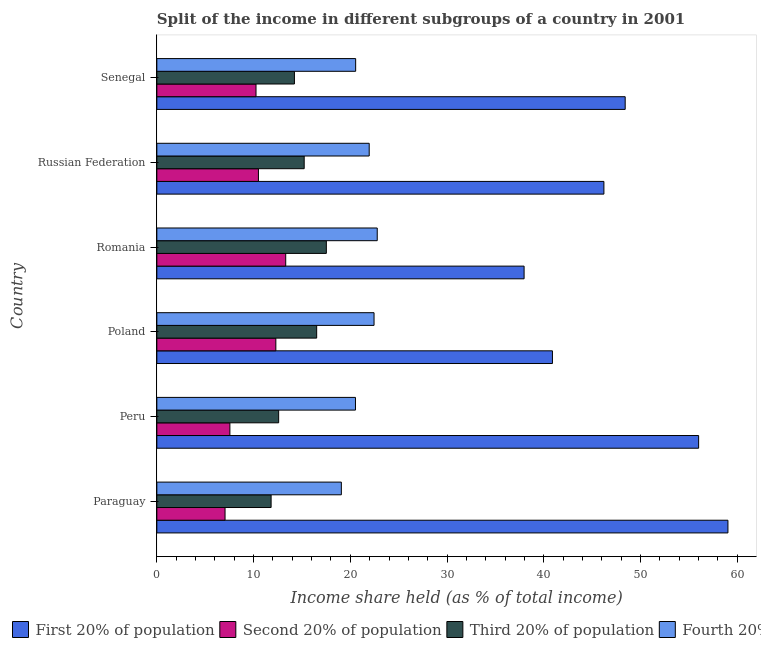How many different coloured bars are there?
Provide a short and direct response. 4. How many groups of bars are there?
Ensure brevity in your answer.  6. What is the label of the 1st group of bars from the top?
Offer a very short reply. Senegal. In how many cases, is the number of bars for a given country not equal to the number of legend labels?
Give a very brief answer. 0. What is the share of the income held by fourth 20% of the population in Russian Federation?
Your answer should be very brief. 21.95. Across all countries, what is the maximum share of the income held by first 20% of the population?
Your response must be concise. 59.03. Across all countries, what is the minimum share of the income held by fourth 20% of the population?
Ensure brevity in your answer.  19.07. In which country was the share of the income held by first 20% of the population maximum?
Provide a succinct answer. Paraguay. In which country was the share of the income held by second 20% of the population minimum?
Offer a very short reply. Paraguay. What is the total share of the income held by first 20% of the population in the graph?
Give a very brief answer. 288.5. What is the difference between the share of the income held by first 20% of the population in Paraguay and the share of the income held by third 20% of the population in Peru?
Make the answer very short. 46.44. What is the average share of the income held by third 20% of the population per country?
Ensure brevity in your answer.  14.65. What is the difference between the share of the income held by fourth 20% of the population and share of the income held by first 20% of the population in Russian Federation?
Keep it short and to the point. -24.26. In how many countries, is the share of the income held by first 20% of the population greater than 54 %?
Keep it short and to the point. 2. Is the share of the income held by third 20% of the population in Romania less than that in Russian Federation?
Provide a succinct answer. No. Is the difference between the share of the income held by first 20% of the population in Poland and Senegal greater than the difference between the share of the income held by second 20% of the population in Poland and Senegal?
Ensure brevity in your answer.  No. What is the difference between the highest and the second highest share of the income held by second 20% of the population?
Provide a short and direct response. 1.02. What is the difference between the highest and the lowest share of the income held by second 20% of the population?
Your response must be concise. 6.27. Is the sum of the share of the income held by first 20% of the population in Peru and Romania greater than the maximum share of the income held by fourth 20% of the population across all countries?
Provide a succinct answer. Yes. Is it the case that in every country, the sum of the share of the income held by third 20% of the population and share of the income held by first 20% of the population is greater than the sum of share of the income held by fourth 20% of the population and share of the income held by second 20% of the population?
Make the answer very short. Yes. What does the 4th bar from the top in Russian Federation represents?
Your answer should be compact. First 20% of population. What does the 2nd bar from the bottom in Poland represents?
Offer a terse response. Second 20% of population. How many countries are there in the graph?
Provide a short and direct response. 6. What is the difference between two consecutive major ticks on the X-axis?
Ensure brevity in your answer.  10. Does the graph contain any zero values?
Your response must be concise. No. Does the graph contain grids?
Provide a short and direct response. No. Where does the legend appear in the graph?
Make the answer very short. Bottom left. How are the legend labels stacked?
Keep it short and to the point. Horizontal. What is the title of the graph?
Provide a short and direct response. Split of the income in different subgroups of a country in 2001. What is the label or title of the X-axis?
Provide a succinct answer. Income share held (as % of total income). What is the label or title of the Y-axis?
Make the answer very short. Country. What is the Income share held (as % of total income) in First 20% of population in Paraguay?
Keep it short and to the point. 59.03. What is the Income share held (as % of total income) of Second 20% of population in Paraguay?
Make the answer very short. 7.05. What is the Income share held (as % of total income) in Third 20% of population in Paraguay?
Provide a short and direct response. 11.81. What is the Income share held (as % of total income) of Fourth 20% of population in Paraguay?
Offer a very short reply. 19.07. What is the Income share held (as % of total income) of Second 20% of population in Peru?
Keep it short and to the point. 7.55. What is the Income share held (as % of total income) in Third 20% of population in Peru?
Your answer should be compact. 12.59. What is the Income share held (as % of total income) in Fourth 20% of population in Peru?
Your response must be concise. 20.53. What is the Income share held (as % of total income) of First 20% of population in Poland?
Your response must be concise. 40.89. What is the Income share held (as % of total income) in Third 20% of population in Poland?
Provide a succinct answer. 16.52. What is the Income share held (as % of total income) of Fourth 20% of population in Poland?
Make the answer very short. 22.45. What is the Income share held (as % of total income) in First 20% of population in Romania?
Your answer should be compact. 37.96. What is the Income share held (as % of total income) in Second 20% of population in Romania?
Offer a very short reply. 13.32. What is the Income share held (as % of total income) in Third 20% of population in Romania?
Provide a short and direct response. 17.52. What is the Income share held (as % of total income) of Fourth 20% of population in Romania?
Offer a terse response. 22.78. What is the Income share held (as % of total income) of First 20% of population in Russian Federation?
Make the answer very short. 46.21. What is the Income share held (as % of total income) of Second 20% of population in Russian Federation?
Make the answer very short. 10.5. What is the Income share held (as % of total income) of Third 20% of population in Russian Federation?
Make the answer very short. 15.23. What is the Income share held (as % of total income) of Fourth 20% of population in Russian Federation?
Offer a terse response. 21.95. What is the Income share held (as % of total income) in First 20% of population in Senegal?
Offer a terse response. 48.41. What is the Income share held (as % of total income) of Second 20% of population in Senegal?
Give a very brief answer. 10.25. What is the Income share held (as % of total income) in Third 20% of population in Senegal?
Your answer should be compact. 14.22. What is the Income share held (as % of total income) of Fourth 20% of population in Senegal?
Ensure brevity in your answer.  20.55. Across all countries, what is the maximum Income share held (as % of total income) of First 20% of population?
Your answer should be compact. 59.03. Across all countries, what is the maximum Income share held (as % of total income) of Second 20% of population?
Offer a terse response. 13.32. Across all countries, what is the maximum Income share held (as % of total income) of Third 20% of population?
Give a very brief answer. 17.52. Across all countries, what is the maximum Income share held (as % of total income) in Fourth 20% of population?
Your response must be concise. 22.78. Across all countries, what is the minimum Income share held (as % of total income) in First 20% of population?
Provide a succinct answer. 37.96. Across all countries, what is the minimum Income share held (as % of total income) in Second 20% of population?
Your answer should be very brief. 7.05. Across all countries, what is the minimum Income share held (as % of total income) of Third 20% of population?
Your answer should be very brief. 11.81. Across all countries, what is the minimum Income share held (as % of total income) of Fourth 20% of population?
Give a very brief answer. 19.07. What is the total Income share held (as % of total income) in First 20% of population in the graph?
Give a very brief answer. 288.5. What is the total Income share held (as % of total income) in Second 20% of population in the graph?
Provide a succinct answer. 60.97. What is the total Income share held (as % of total income) of Third 20% of population in the graph?
Keep it short and to the point. 87.89. What is the total Income share held (as % of total income) of Fourth 20% of population in the graph?
Offer a terse response. 127.33. What is the difference between the Income share held (as % of total income) of First 20% of population in Paraguay and that in Peru?
Give a very brief answer. 3.03. What is the difference between the Income share held (as % of total income) in Third 20% of population in Paraguay and that in Peru?
Your response must be concise. -0.78. What is the difference between the Income share held (as % of total income) of Fourth 20% of population in Paraguay and that in Peru?
Provide a short and direct response. -1.46. What is the difference between the Income share held (as % of total income) in First 20% of population in Paraguay and that in Poland?
Provide a short and direct response. 18.14. What is the difference between the Income share held (as % of total income) of Second 20% of population in Paraguay and that in Poland?
Give a very brief answer. -5.25. What is the difference between the Income share held (as % of total income) in Third 20% of population in Paraguay and that in Poland?
Provide a succinct answer. -4.71. What is the difference between the Income share held (as % of total income) in Fourth 20% of population in Paraguay and that in Poland?
Ensure brevity in your answer.  -3.38. What is the difference between the Income share held (as % of total income) of First 20% of population in Paraguay and that in Romania?
Make the answer very short. 21.07. What is the difference between the Income share held (as % of total income) in Second 20% of population in Paraguay and that in Romania?
Give a very brief answer. -6.27. What is the difference between the Income share held (as % of total income) in Third 20% of population in Paraguay and that in Romania?
Keep it short and to the point. -5.71. What is the difference between the Income share held (as % of total income) of Fourth 20% of population in Paraguay and that in Romania?
Provide a short and direct response. -3.71. What is the difference between the Income share held (as % of total income) in First 20% of population in Paraguay and that in Russian Federation?
Provide a succinct answer. 12.82. What is the difference between the Income share held (as % of total income) of Second 20% of population in Paraguay and that in Russian Federation?
Provide a succinct answer. -3.45. What is the difference between the Income share held (as % of total income) of Third 20% of population in Paraguay and that in Russian Federation?
Give a very brief answer. -3.42. What is the difference between the Income share held (as % of total income) of Fourth 20% of population in Paraguay and that in Russian Federation?
Your answer should be compact. -2.88. What is the difference between the Income share held (as % of total income) in First 20% of population in Paraguay and that in Senegal?
Your answer should be compact. 10.62. What is the difference between the Income share held (as % of total income) in Second 20% of population in Paraguay and that in Senegal?
Offer a terse response. -3.2. What is the difference between the Income share held (as % of total income) of Third 20% of population in Paraguay and that in Senegal?
Your response must be concise. -2.41. What is the difference between the Income share held (as % of total income) in Fourth 20% of population in Paraguay and that in Senegal?
Offer a very short reply. -1.48. What is the difference between the Income share held (as % of total income) in First 20% of population in Peru and that in Poland?
Offer a very short reply. 15.11. What is the difference between the Income share held (as % of total income) in Second 20% of population in Peru and that in Poland?
Make the answer very short. -4.75. What is the difference between the Income share held (as % of total income) of Third 20% of population in Peru and that in Poland?
Ensure brevity in your answer.  -3.93. What is the difference between the Income share held (as % of total income) of Fourth 20% of population in Peru and that in Poland?
Your response must be concise. -1.92. What is the difference between the Income share held (as % of total income) of First 20% of population in Peru and that in Romania?
Make the answer very short. 18.04. What is the difference between the Income share held (as % of total income) in Second 20% of population in Peru and that in Romania?
Your response must be concise. -5.77. What is the difference between the Income share held (as % of total income) of Third 20% of population in Peru and that in Romania?
Your response must be concise. -4.93. What is the difference between the Income share held (as % of total income) of Fourth 20% of population in Peru and that in Romania?
Provide a succinct answer. -2.25. What is the difference between the Income share held (as % of total income) of First 20% of population in Peru and that in Russian Federation?
Ensure brevity in your answer.  9.79. What is the difference between the Income share held (as % of total income) of Second 20% of population in Peru and that in Russian Federation?
Offer a very short reply. -2.95. What is the difference between the Income share held (as % of total income) of Third 20% of population in Peru and that in Russian Federation?
Offer a very short reply. -2.64. What is the difference between the Income share held (as % of total income) of Fourth 20% of population in Peru and that in Russian Federation?
Provide a succinct answer. -1.42. What is the difference between the Income share held (as % of total income) of First 20% of population in Peru and that in Senegal?
Your answer should be compact. 7.59. What is the difference between the Income share held (as % of total income) in Third 20% of population in Peru and that in Senegal?
Your answer should be compact. -1.63. What is the difference between the Income share held (as % of total income) in Fourth 20% of population in Peru and that in Senegal?
Ensure brevity in your answer.  -0.02. What is the difference between the Income share held (as % of total income) of First 20% of population in Poland and that in Romania?
Your answer should be compact. 2.93. What is the difference between the Income share held (as % of total income) in Second 20% of population in Poland and that in Romania?
Offer a very short reply. -1.02. What is the difference between the Income share held (as % of total income) in Third 20% of population in Poland and that in Romania?
Provide a short and direct response. -1. What is the difference between the Income share held (as % of total income) in Fourth 20% of population in Poland and that in Romania?
Make the answer very short. -0.33. What is the difference between the Income share held (as % of total income) of First 20% of population in Poland and that in Russian Federation?
Give a very brief answer. -5.32. What is the difference between the Income share held (as % of total income) in Second 20% of population in Poland and that in Russian Federation?
Make the answer very short. 1.8. What is the difference between the Income share held (as % of total income) of Third 20% of population in Poland and that in Russian Federation?
Make the answer very short. 1.29. What is the difference between the Income share held (as % of total income) of Fourth 20% of population in Poland and that in Russian Federation?
Provide a short and direct response. 0.5. What is the difference between the Income share held (as % of total income) in First 20% of population in Poland and that in Senegal?
Give a very brief answer. -7.52. What is the difference between the Income share held (as % of total income) of Second 20% of population in Poland and that in Senegal?
Provide a short and direct response. 2.05. What is the difference between the Income share held (as % of total income) in Third 20% of population in Poland and that in Senegal?
Offer a very short reply. 2.3. What is the difference between the Income share held (as % of total income) in Fourth 20% of population in Poland and that in Senegal?
Your response must be concise. 1.9. What is the difference between the Income share held (as % of total income) in First 20% of population in Romania and that in Russian Federation?
Provide a succinct answer. -8.25. What is the difference between the Income share held (as % of total income) in Second 20% of population in Romania and that in Russian Federation?
Make the answer very short. 2.82. What is the difference between the Income share held (as % of total income) of Third 20% of population in Romania and that in Russian Federation?
Offer a terse response. 2.29. What is the difference between the Income share held (as % of total income) of Fourth 20% of population in Romania and that in Russian Federation?
Keep it short and to the point. 0.83. What is the difference between the Income share held (as % of total income) in First 20% of population in Romania and that in Senegal?
Provide a short and direct response. -10.45. What is the difference between the Income share held (as % of total income) in Second 20% of population in Romania and that in Senegal?
Give a very brief answer. 3.07. What is the difference between the Income share held (as % of total income) of Third 20% of population in Romania and that in Senegal?
Make the answer very short. 3.3. What is the difference between the Income share held (as % of total income) in Fourth 20% of population in Romania and that in Senegal?
Your response must be concise. 2.23. What is the difference between the Income share held (as % of total income) in First 20% of population in Russian Federation and that in Senegal?
Ensure brevity in your answer.  -2.2. What is the difference between the Income share held (as % of total income) of First 20% of population in Paraguay and the Income share held (as % of total income) of Second 20% of population in Peru?
Offer a terse response. 51.48. What is the difference between the Income share held (as % of total income) in First 20% of population in Paraguay and the Income share held (as % of total income) in Third 20% of population in Peru?
Ensure brevity in your answer.  46.44. What is the difference between the Income share held (as % of total income) in First 20% of population in Paraguay and the Income share held (as % of total income) in Fourth 20% of population in Peru?
Provide a short and direct response. 38.5. What is the difference between the Income share held (as % of total income) of Second 20% of population in Paraguay and the Income share held (as % of total income) of Third 20% of population in Peru?
Your response must be concise. -5.54. What is the difference between the Income share held (as % of total income) in Second 20% of population in Paraguay and the Income share held (as % of total income) in Fourth 20% of population in Peru?
Offer a terse response. -13.48. What is the difference between the Income share held (as % of total income) in Third 20% of population in Paraguay and the Income share held (as % of total income) in Fourth 20% of population in Peru?
Keep it short and to the point. -8.72. What is the difference between the Income share held (as % of total income) of First 20% of population in Paraguay and the Income share held (as % of total income) of Second 20% of population in Poland?
Provide a succinct answer. 46.73. What is the difference between the Income share held (as % of total income) of First 20% of population in Paraguay and the Income share held (as % of total income) of Third 20% of population in Poland?
Provide a succinct answer. 42.51. What is the difference between the Income share held (as % of total income) in First 20% of population in Paraguay and the Income share held (as % of total income) in Fourth 20% of population in Poland?
Your answer should be very brief. 36.58. What is the difference between the Income share held (as % of total income) in Second 20% of population in Paraguay and the Income share held (as % of total income) in Third 20% of population in Poland?
Keep it short and to the point. -9.47. What is the difference between the Income share held (as % of total income) of Second 20% of population in Paraguay and the Income share held (as % of total income) of Fourth 20% of population in Poland?
Give a very brief answer. -15.4. What is the difference between the Income share held (as % of total income) of Third 20% of population in Paraguay and the Income share held (as % of total income) of Fourth 20% of population in Poland?
Make the answer very short. -10.64. What is the difference between the Income share held (as % of total income) of First 20% of population in Paraguay and the Income share held (as % of total income) of Second 20% of population in Romania?
Offer a very short reply. 45.71. What is the difference between the Income share held (as % of total income) of First 20% of population in Paraguay and the Income share held (as % of total income) of Third 20% of population in Romania?
Offer a terse response. 41.51. What is the difference between the Income share held (as % of total income) in First 20% of population in Paraguay and the Income share held (as % of total income) in Fourth 20% of population in Romania?
Give a very brief answer. 36.25. What is the difference between the Income share held (as % of total income) in Second 20% of population in Paraguay and the Income share held (as % of total income) in Third 20% of population in Romania?
Provide a short and direct response. -10.47. What is the difference between the Income share held (as % of total income) of Second 20% of population in Paraguay and the Income share held (as % of total income) of Fourth 20% of population in Romania?
Your response must be concise. -15.73. What is the difference between the Income share held (as % of total income) in Third 20% of population in Paraguay and the Income share held (as % of total income) in Fourth 20% of population in Romania?
Give a very brief answer. -10.97. What is the difference between the Income share held (as % of total income) in First 20% of population in Paraguay and the Income share held (as % of total income) in Second 20% of population in Russian Federation?
Provide a short and direct response. 48.53. What is the difference between the Income share held (as % of total income) in First 20% of population in Paraguay and the Income share held (as % of total income) in Third 20% of population in Russian Federation?
Your response must be concise. 43.8. What is the difference between the Income share held (as % of total income) of First 20% of population in Paraguay and the Income share held (as % of total income) of Fourth 20% of population in Russian Federation?
Your answer should be very brief. 37.08. What is the difference between the Income share held (as % of total income) in Second 20% of population in Paraguay and the Income share held (as % of total income) in Third 20% of population in Russian Federation?
Your answer should be very brief. -8.18. What is the difference between the Income share held (as % of total income) of Second 20% of population in Paraguay and the Income share held (as % of total income) of Fourth 20% of population in Russian Federation?
Give a very brief answer. -14.9. What is the difference between the Income share held (as % of total income) of Third 20% of population in Paraguay and the Income share held (as % of total income) of Fourth 20% of population in Russian Federation?
Offer a terse response. -10.14. What is the difference between the Income share held (as % of total income) of First 20% of population in Paraguay and the Income share held (as % of total income) of Second 20% of population in Senegal?
Provide a succinct answer. 48.78. What is the difference between the Income share held (as % of total income) of First 20% of population in Paraguay and the Income share held (as % of total income) of Third 20% of population in Senegal?
Provide a short and direct response. 44.81. What is the difference between the Income share held (as % of total income) in First 20% of population in Paraguay and the Income share held (as % of total income) in Fourth 20% of population in Senegal?
Your answer should be very brief. 38.48. What is the difference between the Income share held (as % of total income) in Second 20% of population in Paraguay and the Income share held (as % of total income) in Third 20% of population in Senegal?
Ensure brevity in your answer.  -7.17. What is the difference between the Income share held (as % of total income) of Third 20% of population in Paraguay and the Income share held (as % of total income) of Fourth 20% of population in Senegal?
Your answer should be compact. -8.74. What is the difference between the Income share held (as % of total income) in First 20% of population in Peru and the Income share held (as % of total income) in Second 20% of population in Poland?
Keep it short and to the point. 43.7. What is the difference between the Income share held (as % of total income) of First 20% of population in Peru and the Income share held (as % of total income) of Third 20% of population in Poland?
Offer a terse response. 39.48. What is the difference between the Income share held (as % of total income) of First 20% of population in Peru and the Income share held (as % of total income) of Fourth 20% of population in Poland?
Make the answer very short. 33.55. What is the difference between the Income share held (as % of total income) of Second 20% of population in Peru and the Income share held (as % of total income) of Third 20% of population in Poland?
Ensure brevity in your answer.  -8.97. What is the difference between the Income share held (as % of total income) in Second 20% of population in Peru and the Income share held (as % of total income) in Fourth 20% of population in Poland?
Make the answer very short. -14.9. What is the difference between the Income share held (as % of total income) of Third 20% of population in Peru and the Income share held (as % of total income) of Fourth 20% of population in Poland?
Provide a short and direct response. -9.86. What is the difference between the Income share held (as % of total income) in First 20% of population in Peru and the Income share held (as % of total income) in Second 20% of population in Romania?
Your response must be concise. 42.68. What is the difference between the Income share held (as % of total income) in First 20% of population in Peru and the Income share held (as % of total income) in Third 20% of population in Romania?
Offer a terse response. 38.48. What is the difference between the Income share held (as % of total income) of First 20% of population in Peru and the Income share held (as % of total income) of Fourth 20% of population in Romania?
Make the answer very short. 33.22. What is the difference between the Income share held (as % of total income) in Second 20% of population in Peru and the Income share held (as % of total income) in Third 20% of population in Romania?
Your answer should be very brief. -9.97. What is the difference between the Income share held (as % of total income) in Second 20% of population in Peru and the Income share held (as % of total income) in Fourth 20% of population in Romania?
Your answer should be compact. -15.23. What is the difference between the Income share held (as % of total income) of Third 20% of population in Peru and the Income share held (as % of total income) of Fourth 20% of population in Romania?
Provide a short and direct response. -10.19. What is the difference between the Income share held (as % of total income) of First 20% of population in Peru and the Income share held (as % of total income) of Second 20% of population in Russian Federation?
Make the answer very short. 45.5. What is the difference between the Income share held (as % of total income) in First 20% of population in Peru and the Income share held (as % of total income) in Third 20% of population in Russian Federation?
Provide a short and direct response. 40.77. What is the difference between the Income share held (as % of total income) in First 20% of population in Peru and the Income share held (as % of total income) in Fourth 20% of population in Russian Federation?
Offer a terse response. 34.05. What is the difference between the Income share held (as % of total income) in Second 20% of population in Peru and the Income share held (as % of total income) in Third 20% of population in Russian Federation?
Provide a short and direct response. -7.68. What is the difference between the Income share held (as % of total income) of Second 20% of population in Peru and the Income share held (as % of total income) of Fourth 20% of population in Russian Federation?
Offer a terse response. -14.4. What is the difference between the Income share held (as % of total income) of Third 20% of population in Peru and the Income share held (as % of total income) of Fourth 20% of population in Russian Federation?
Make the answer very short. -9.36. What is the difference between the Income share held (as % of total income) in First 20% of population in Peru and the Income share held (as % of total income) in Second 20% of population in Senegal?
Your answer should be compact. 45.75. What is the difference between the Income share held (as % of total income) in First 20% of population in Peru and the Income share held (as % of total income) in Third 20% of population in Senegal?
Offer a very short reply. 41.78. What is the difference between the Income share held (as % of total income) of First 20% of population in Peru and the Income share held (as % of total income) of Fourth 20% of population in Senegal?
Provide a short and direct response. 35.45. What is the difference between the Income share held (as % of total income) of Second 20% of population in Peru and the Income share held (as % of total income) of Third 20% of population in Senegal?
Offer a terse response. -6.67. What is the difference between the Income share held (as % of total income) of Third 20% of population in Peru and the Income share held (as % of total income) of Fourth 20% of population in Senegal?
Give a very brief answer. -7.96. What is the difference between the Income share held (as % of total income) in First 20% of population in Poland and the Income share held (as % of total income) in Second 20% of population in Romania?
Give a very brief answer. 27.57. What is the difference between the Income share held (as % of total income) in First 20% of population in Poland and the Income share held (as % of total income) in Third 20% of population in Romania?
Ensure brevity in your answer.  23.37. What is the difference between the Income share held (as % of total income) in First 20% of population in Poland and the Income share held (as % of total income) in Fourth 20% of population in Romania?
Provide a short and direct response. 18.11. What is the difference between the Income share held (as % of total income) of Second 20% of population in Poland and the Income share held (as % of total income) of Third 20% of population in Romania?
Give a very brief answer. -5.22. What is the difference between the Income share held (as % of total income) of Second 20% of population in Poland and the Income share held (as % of total income) of Fourth 20% of population in Romania?
Your answer should be very brief. -10.48. What is the difference between the Income share held (as % of total income) of Third 20% of population in Poland and the Income share held (as % of total income) of Fourth 20% of population in Romania?
Offer a very short reply. -6.26. What is the difference between the Income share held (as % of total income) in First 20% of population in Poland and the Income share held (as % of total income) in Second 20% of population in Russian Federation?
Your response must be concise. 30.39. What is the difference between the Income share held (as % of total income) in First 20% of population in Poland and the Income share held (as % of total income) in Third 20% of population in Russian Federation?
Keep it short and to the point. 25.66. What is the difference between the Income share held (as % of total income) in First 20% of population in Poland and the Income share held (as % of total income) in Fourth 20% of population in Russian Federation?
Your answer should be compact. 18.94. What is the difference between the Income share held (as % of total income) of Second 20% of population in Poland and the Income share held (as % of total income) of Third 20% of population in Russian Federation?
Your answer should be very brief. -2.93. What is the difference between the Income share held (as % of total income) in Second 20% of population in Poland and the Income share held (as % of total income) in Fourth 20% of population in Russian Federation?
Your response must be concise. -9.65. What is the difference between the Income share held (as % of total income) of Third 20% of population in Poland and the Income share held (as % of total income) of Fourth 20% of population in Russian Federation?
Your answer should be compact. -5.43. What is the difference between the Income share held (as % of total income) in First 20% of population in Poland and the Income share held (as % of total income) in Second 20% of population in Senegal?
Keep it short and to the point. 30.64. What is the difference between the Income share held (as % of total income) of First 20% of population in Poland and the Income share held (as % of total income) of Third 20% of population in Senegal?
Your answer should be compact. 26.67. What is the difference between the Income share held (as % of total income) of First 20% of population in Poland and the Income share held (as % of total income) of Fourth 20% of population in Senegal?
Keep it short and to the point. 20.34. What is the difference between the Income share held (as % of total income) of Second 20% of population in Poland and the Income share held (as % of total income) of Third 20% of population in Senegal?
Give a very brief answer. -1.92. What is the difference between the Income share held (as % of total income) of Second 20% of population in Poland and the Income share held (as % of total income) of Fourth 20% of population in Senegal?
Your answer should be compact. -8.25. What is the difference between the Income share held (as % of total income) in Third 20% of population in Poland and the Income share held (as % of total income) in Fourth 20% of population in Senegal?
Give a very brief answer. -4.03. What is the difference between the Income share held (as % of total income) in First 20% of population in Romania and the Income share held (as % of total income) in Second 20% of population in Russian Federation?
Provide a short and direct response. 27.46. What is the difference between the Income share held (as % of total income) in First 20% of population in Romania and the Income share held (as % of total income) in Third 20% of population in Russian Federation?
Offer a very short reply. 22.73. What is the difference between the Income share held (as % of total income) in First 20% of population in Romania and the Income share held (as % of total income) in Fourth 20% of population in Russian Federation?
Your answer should be very brief. 16.01. What is the difference between the Income share held (as % of total income) in Second 20% of population in Romania and the Income share held (as % of total income) in Third 20% of population in Russian Federation?
Keep it short and to the point. -1.91. What is the difference between the Income share held (as % of total income) of Second 20% of population in Romania and the Income share held (as % of total income) of Fourth 20% of population in Russian Federation?
Provide a short and direct response. -8.63. What is the difference between the Income share held (as % of total income) of Third 20% of population in Romania and the Income share held (as % of total income) of Fourth 20% of population in Russian Federation?
Offer a very short reply. -4.43. What is the difference between the Income share held (as % of total income) of First 20% of population in Romania and the Income share held (as % of total income) of Second 20% of population in Senegal?
Provide a succinct answer. 27.71. What is the difference between the Income share held (as % of total income) of First 20% of population in Romania and the Income share held (as % of total income) of Third 20% of population in Senegal?
Your answer should be compact. 23.74. What is the difference between the Income share held (as % of total income) of First 20% of population in Romania and the Income share held (as % of total income) of Fourth 20% of population in Senegal?
Provide a succinct answer. 17.41. What is the difference between the Income share held (as % of total income) of Second 20% of population in Romania and the Income share held (as % of total income) of Fourth 20% of population in Senegal?
Ensure brevity in your answer.  -7.23. What is the difference between the Income share held (as % of total income) in Third 20% of population in Romania and the Income share held (as % of total income) in Fourth 20% of population in Senegal?
Your answer should be compact. -3.03. What is the difference between the Income share held (as % of total income) of First 20% of population in Russian Federation and the Income share held (as % of total income) of Second 20% of population in Senegal?
Offer a terse response. 35.96. What is the difference between the Income share held (as % of total income) of First 20% of population in Russian Federation and the Income share held (as % of total income) of Third 20% of population in Senegal?
Your response must be concise. 31.99. What is the difference between the Income share held (as % of total income) of First 20% of population in Russian Federation and the Income share held (as % of total income) of Fourth 20% of population in Senegal?
Keep it short and to the point. 25.66. What is the difference between the Income share held (as % of total income) in Second 20% of population in Russian Federation and the Income share held (as % of total income) in Third 20% of population in Senegal?
Offer a very short reply. -3.72. What is the difference between the Income share held (as % of total income) of Second 20% of population in Russian Federation and the Income share held (as % of total income) of Fourth 20% of population in Senegal?
Provide a succinct answer. -10.05. What is the difference between the Income share held (as % of total income) of Third 20% of population in Russian Federation and the Income share held (as % of total income) of Fourth 20% of population in Senegal?
Your answer should be very brief. -5.32. What is the average Income share held (as % of total income) in First 20% of population per country?
Ensure brevity in your answer.  48.08. What is the average Income share held (as % of total income) in Second 20% of population per country?
Make the answer very short. 10.16. What is the average Income share held (as % of total income) in Third 20% of population per country?
Provide a succinct answer. 14.65. What is the average Income share held (as % of total income) in Fourth 20% of population per country?
Make the answer very short. 21.22. What is the difference between the Income share held (as % of total income) of First 20% of population and Income share held (as % of total income) of Second 20% of population in Paraguay?
Provide a short and direct response. 51.98. What is the difference between the Income share held (as % of total income) of First 20% of population and Income share held (as % of total income) of Third 20% of population in Paraguay?
Provide a succinct answer. 47.22. What is the difference between the Income share held (as % of total income) in First 20% of population and Income share held (as % of total income) in Fourth 20% of population in Paraguay?
Provide a succinct answer. 39.96. What is the difference between the Income share held (as % of total income) of Second 20% of population and Income share held (as % of total income) of Third 20% of population in Paraguay?
Keep it short and to the point. -4.76. What is the difference between the Income share held (as % of total income) in Second 20% of population and Income share held (as % of total income) in Fourth 20% of population in Paraguay?
Make the answer very short. -12.02. What is the difference between the Income share held (as % of total income) of Third 20% of population and Income share held (as % of total income) of Fourth 20% of population in Paraguay?
Provide a short and direct response. -7.26. What is the difference between the Income share held (as % of total income) of First 20% of population and Income share held (as % of total income) of Second 20% of population in Peru?
Give a very brief answer. 48.45. What is the difference between the Income share held (as % of total income) in First 20% of population and Income share held (as % of total income) in Third 20% of population in Peru?
Offer a very short reply. 43.41. What is the difference between the Income share held (as % of total income) in First 20% of population and Income share held (as % of total income) in Fourth 20% of population in Peru?
Your answer should be compact. 35.47. What is the difference between the Income share held (as % of total income) in Second 20% of population and Income share held (as % of total income) in Third 20% of population in Peru?
Provide a short and direct response. -5.04. What is the difference between the Income share held (as % of total income) in Second 20% of population and Income share held (as % of total income) in Fourth 20% of population in Peru?
Offer a terse response. -12.98. What is the difference between the Income share held (as % of total income) in Third 20% of population and Income share held (as % of total income) in Fourth 20% of population in Peru?
Give a very brief answer. -7.94. What is the difference between the Income share held (as % of total income) in First 20% of population and Income share held (as % of total income) in Second 20% of population in Poland?
Ensure brevity in your answer.  28.59. What is the difference between the Income share held (as % of total income) of First 20% of population and Income share held (as % of total income) of Third 20% of population in Poland?
Provide a succinct answer. 24.37. What is the difference between the Income share held (as % of total income) in First 20% of population and Income share held (as % of total income) in Fourth 20% of population in Poland?
Make the answer very short. 18.44. What is the difference between the Income share held (as % of total income) of Second 20% of population and Income share held (as % of total income) of Third 20% of population in Poland?
Provide a short and direct response. -4.22. What is the difference between the Income share held (as % of total income) in Second 20% of population and Income share held (as % of total income) in Fourth 20% of population in Poland?
Keep it short and to the point. -10.15. What is the difference between the Income share held (as % of total income) of Third 20% of population and Income share held (as % of total income) of Fourth 20% of population in Poland?
Offer a very short reply. -5.93. What is the difference between the Income share held (as % of total income) of First 20% of population and Income share held (as % of total income) of Second 20% of population in Romania?
Give a very brief answer. 24.64. What is the difference between the Income share held (as % of total income) in First 20% of population and Income share held (as % of total income) in Third 20% of population in Romania?
Offer a very short reply. 20.44. What is the difference between the Income share held (as % of total income) of First 20% of population and Income share held (as % of total income) of Fourth 20% of population in Romania?
Give a very brief answer. 15.18. What is the difference between the Income share held (as % of total income) in Second 20% of population and Income share held (as % of total income) in Fourth 20% of population in Romania?
Ensure brevity in your answer.  -9.46. What is the difference between the Income share held (as % of total income) in Third 20% of population and Income share held (as % of total income) in Fourth 20% of population in Romania?
Give a very brief answer. -5.26. What is the difference between the Income share held (as % of total income) of First 20% of population and Income share held (as % of total income) of Second 20% of population in Russian Federation?
Provide a short and direct response. 35.71. What is the difference between the Income share held (as % of total income) in First 20% of population and Income share held (as % of total income) in Third 20% of population in Russian Federation?
Your answer should be compact. 30.98. What is the difference between the Income share held (as % of total income) of First 20% of population and Income share held (as % of total income) of Fourth 20% of population in Russian Federation?
Your answer should be very brief. 24.26. What is the difference between the Income share held (as % of total income) of Second 20% of population and Income share held (as % of total income) of Third 20% of population in Russian Federation?
Ensure brevity in your answer.  -4.73. What is the difference between the Income share held (as % of total income) of Second 20% of population and Income share held (as % of total income) of Fourth 20% of population in Russian Federation?
Your answer should be very brief. -11.45. What is the difference between the Income share held (as % of total income) in Third 20% of population and Income share held (as % of total income) in Fourth 20% of population in Russian Federation?
Ensure brevity in your answer.  -6.72. What is the difference between the Income share held (as % of total income) of First 20% of population and Income share held (as % of total income) of Second 20% of population in Senegal?
Keep it short and to the point. 38.16. What is the difference between the Income share held (as % of total income) of First 20% of population and Income share held (as % of total income) of Third 20% of population in Senegal?
Offer a very short reply. 34.19. What is the difference between the Income share held (as % of total income) of First 20% of population and Income share held (as % of total income) of Fourth 20% of population in Senegal?
Ensure brevity in your answer.  27.86. What is the difference between the Income share held (as % of total income) of Second 20% of population and Income share held (as % of total income) of Third 20% of population in Senegal?
Your answer should be very brief. -3.97. What is the difference between the Income share held (as % of total income) of Second 20% of population and Income share held (as % of total income) of Fourth 20% of population in Senegal?
Make the answer very short. -10.3. What is the difference between the Income share held (as % of total income) of Third 20% of population and Income share held (as % of total income) of Fourth 20% of population in Senegal?
Give a very brief answer. -6.33. What is the ratio of the Income share held (as % of total income) in First 20% of population in Paraguay to that in Peru?
Offer a terse response. 1.05. What is the ratio of the Income share held (as % of total income) in Second 20% of population in Paraguay to that in Peru?
Ensure brevity in your answer.  0.93. What is the ratio of the Income share held (as % of total income) in Third 20% of population in Paraguay to that in Peru?
Provide a short and direct response. 0.94. What is the ratio of the Income share held (as % of total income) of Fourth 20% of population in Paraguay to that in Peru?
Ensure brevity in your answer.  0.93. What is the ratio of the Income share held (as % of total income) in First 20% of population in Paraguay to that in Poland?
Your response must be concise. 1.44. What is the ratio of the Income share held (as % of total income) of Second 20% of population in Paraguay to that in Poland?
Your answer should be compact. 0.57. What is the ratio of the Income share held (as % of total income) of Third 20% of population in Paraguay to that in Poland?
Offer a very short reply. 0.71. What is the ratio of the Income share held (as % of total income) of Fourth 20% of population in Paraguay to that in Poland?
Your response must be concise. 0.85. What is the ratio of the Income share held (as % of total income) of First 20% of population in Paraguay to that in Romania?
Offer a very short reply. 1.56. What is the ratio of the Income share held (as % of total income) in Second 20% of population in Paraguay to that in Romania?
Make the answer very short. 0.53. What is the ratio of the Income share held (as % of total income) in Third 20% of population in Paraguay to that in Romania?
Give a very brief answer. 0.67. What is the ratio of the Income share held (as % of total income) of Fourth 20% of population in Paraguay to that in Romania?
Give a very brief answer. 0.84. What is the ratio of the Income share held (as % of total income) in First 20% of population in Paraguay to that in Russian Federation?
Keep it short and to the point. 1.28. What is the ratio of the Income share held (as % of total income) in Second 20% of population in Paraguay to that in Russian Federation?
Offer a very short reply. 0.67. What is the ratio of the Income share held (as % of total income) of Third 20% of population in Paraguay to that in Russian Federation?
Your answer should be compact. 0.78. What is the ratio of the Income share held (as % of total income) of Fourth 20% of population in Paraguay to that in Russian Federation?
Give a very brief answer. 0.87. What is the ratio of the Income share held (as % of total income) in First 20% of population in Paraguay to that in Senegal?
Keep it short and to the point. 1.22. What is the ratio of the Income share held (as % of total income) in Second 20% of population in Paraguay to that in Senegal?
Your answer should be compact. 0.69. What is the ratio of the Income share held (as % of total income) in Third 20% of population in Paraguay to that in Senegal?
Make the answer very short. 0.83. What is the ratio of the Income share held (as % of total income) of Fourth 20% of population in Paraguay to that in Senegal?
Your answer should be compact. 0.93. What is the ratio of the Income share held (as % of total income) of First 20% of population in Peru to that in Poland?
Your answer should be compact. 1.37. What is the ratio of the Income share held (as % of total income) of Second 20% of population in Peru to that in Poland?
Offer a very short reply. 0.61. What is the ratio of the Income share held (as % of total income) of Third 20% of population in Peru to that in Poland?
Ensure brevity in your answer.  0.76. What is the ratio of the Income share held (as % of total income) of Fourth 20% of population in Peru to that in Poland?
Your response must be concise. 0.91. What is the ratio of the Income share held (as % of total income) of First 20% of population in Peru to that in Romania?
Your answer should be very brief. 1.48. What is the ratio of the Income share held (as % of total income) of Second 20% of population in Peru to that in Romania?
Give a very brief answer. 0.57. What is the ratio of the Income share held (as % of total income) of Third 20% of population in Peru to that in Romania?
Provide a short and direct response. 0.72. What is the ratio of the Income share held (as % of total income) of Fourth 20% of population in Peru to that in Romania?
Give a very brief answer. 0.9. What is the ratio of the Income share held (as % of total income) in First 20% of population in Peru to that in Russian Federation?
Offer a very short reply. 1.21. What is the ratio of the Income share held (as % of total income) of Second 20% of population in Peru to that in Russian Federation?
Your response must be concise. 0.72. What is the ratio of the Income share held (as % of total income) of Third 20% of population in Peru to that in Russian Federation?
Offer a terse response. 0.83. What is the ratio of the Income share held (as % of total income) of Fourth 20% of population in Peru to that in Russian Federation?
Provide a short and direct response. 0.94. What is the ratio of the Income share held (as % of total income) in First 20% of population in Peru to that in Senegal?
Offer a terse response. 1.16. What is the ratio of the Income share held (as % of total income) of Second 20% of population in Peru to that in Senegal?
Provide a short and direct response. 0.74. What is the ratio of the Income share held (as % of total income) of Third 20% of population in Peru to that in Senegal?
Your answer should be compact. 0.89. What is the ratio of the Income share held (as % of total income) in First 20% of population in Poland to that in Romania?
Offer a terse response. 1.08. What is the ratio of the Income share held (as % of total income) of Second 20% of population in Poland to that in Romania?
Your answer should be compact. 0.92. What is the ratio of the Income share held (as % of total income) of Third 20% of population in Poland to that in Romania?
Offer a terse response. 0.94. What is the ratio of the Income share held (as % of total income) of Fourth 20% of population in Poland to that in Romania?
Provide a succinct answer. 0.99. What is the ratio of the Income share held (as % of total income) in First 20% of population in Poland to that in Russian Federation?
Ensure brevity in your answer.  0.88. What is the ratio of the Income share held (as % of total income) of Second 20% of population in Poland to that in Russian Federation?
Provide a short and direct response. 1.17. What is the ratio of the Income share held (as % of total income) in Third 20% of population in Poland to that in Russian Federation?
Give a very brief answer. 1.08. What is the ratio of the Income share held (as % of total income) of Fourth 20% of population in Poland to that in Russian Federation?
Make the answer very short. 1.02. What is the ratio of the Income share held (as % of total income) in First 20% of population in Poland to that in Senegal?
Your answer should be very brief. 0.84. What is the ratio of the Income share held (as % of total income) of Third 20% of population in Poland to that in Senegal?
Provide a succinct answer. 1.16. What is the ratio of the Income share held (as % of total income) of Fourth 20% of population in Poland to that in Senegal?
Your answer should be very brief. 1.09. What is the ratio of the Income share held (as % of total income) of First 20% of population in Romania to that in Russian Federation?
Keep it short and to the point. 0.82. What is the ratio of the Income share held (as % of total income) in Second 20% of population in Romania to that in Russian Federation?
Keep it short and to the point. 1.27. What is the ratio of the Income share held (as % of total income) of Third 20% of population in Romania to that in Russian Federation?
Your answer should be compact. 1.15. What is the ratio of the Income share held (as % of total income) in Fourth 20% of population in Romania to that in Russian Federation?
Your answer should be very brief. 1.04. What is the ratio of the Income share held (as % of total income) in First 20% of population in Romania to that in Senegal?
Offer a terse response. 0.78. What is the ratio of the Income share held (as % of total income) of Second 20% of population in Romania to that in Senegal?
Your response must be concise. 1.3. What is the ratio of the Income share held (as % of total income) in Third 20% of population in Romania to that in Senegal?
Offer a terse response. 1.23. What is the ratio of the Income share held (as % of total income) of Fourth 20% of population in Romania to that in Senegal?
Provide a succinct answer. 1.11. What is the ratio of the Income share held (as % of total income) in First 20% of population in Russian Federation to that in Senegal?
Provide a succinct answer. 0.95. What is the ratio of the Income share held (as % of total income) in Second 20% of population in Russian Federation to that in Senegal?
Your answer should be very brief. 1.02. What is the ratio of the Income share held (as % of total income) in Third 20% of population in Russian Federation to that in Senegal?
Provide a succinct answer. 1.07. What is the ratio of the Income share held (as % of total income) of Fourth 20% of population in Russian Federation to that in Senegal?
Keep it short and to the point. 1.07. What is the difference between the highest and the second highest Income share held (as % of total income) in First 20% of population?
Keep it short and to the point. 3.03. What is the difference between the highest and the second highest Income share held (as % of total income) of Third 20% of population?
Your response must be concise. 1. What is the difference between the highest and the second highest Income share held (as % of total income) of Fourth 20% of population?
Offer a very short reply. 0.33. What is the difference between the highest and the lowest Income share held (as % of total income) of First 20% of population?
Your answer should be very brief. 21.07. What is the difference between the highest and the lowest Income share held (as % of total income) in Second 20% of population?
Your answer should be compact. 6.27. What is the difference between the highest and the lowest Income share held (as % of total income) in Third 20% of population?
Give a very brief answer. 5.71. What is the difference between the highest and the lowest Income share held (as % of total income) in Fourth 20% of population?
Offer a very short reply. 3.71. 